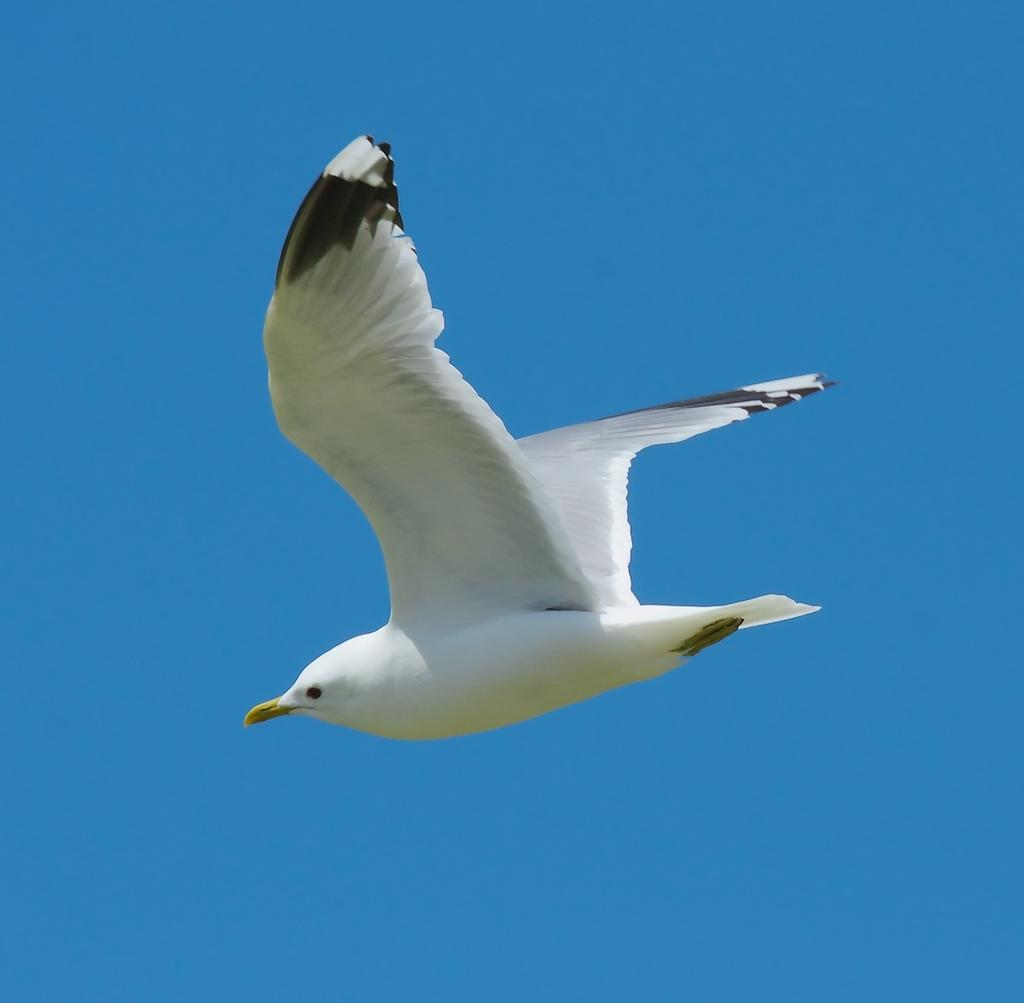What type of animal can be seen in the image? There is a bird in the image. What is the bird doing in the image? The bird is flying in the sky. What is the bird's care routine in the image? There is no information about the bird's care routine in the image, as it only shows the bird flying in the sky. 